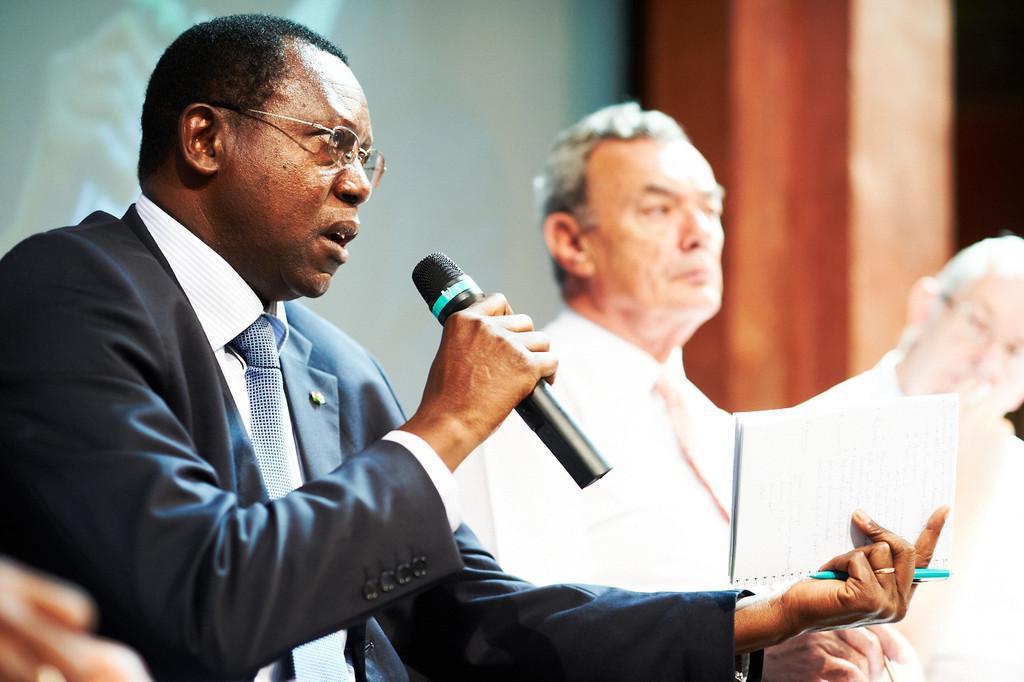Can you describe this image briefly? In this picture is talking with mic in his one his hands and book in his other hand. In the picture we also observe two men who are dressed in white color and sitting beside him. In the background we observe a wooden pillar and a wall painting. 